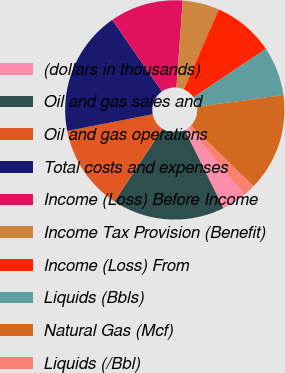Convert chart. <chart><loc_0><loc_0><loc_500><loc_500><pie_chart><fcel>(dollars in thousands)<fcel>Oil and gas sales and<fcel>Oil and gas operations<fcel>Total costs and expenses<fcel>Income (Loss) Before Income<fcel>Income Tax Provision (Benefit)<fcel>Income (Loss) From<fcel>Liquids (Bbls)<fcel>Natural Gas (Mcf)<fcel>Liquids (/Bbl)<nl><fcel>3.61%<fcel>16.6%<fcel>12.64%<fcel>18.4%<fcel>10.83%<fcel>5.42%<fcel>9.03%<fcel>7.22%<fcel>14.44%<fcel>1.81%<nl></chart> 